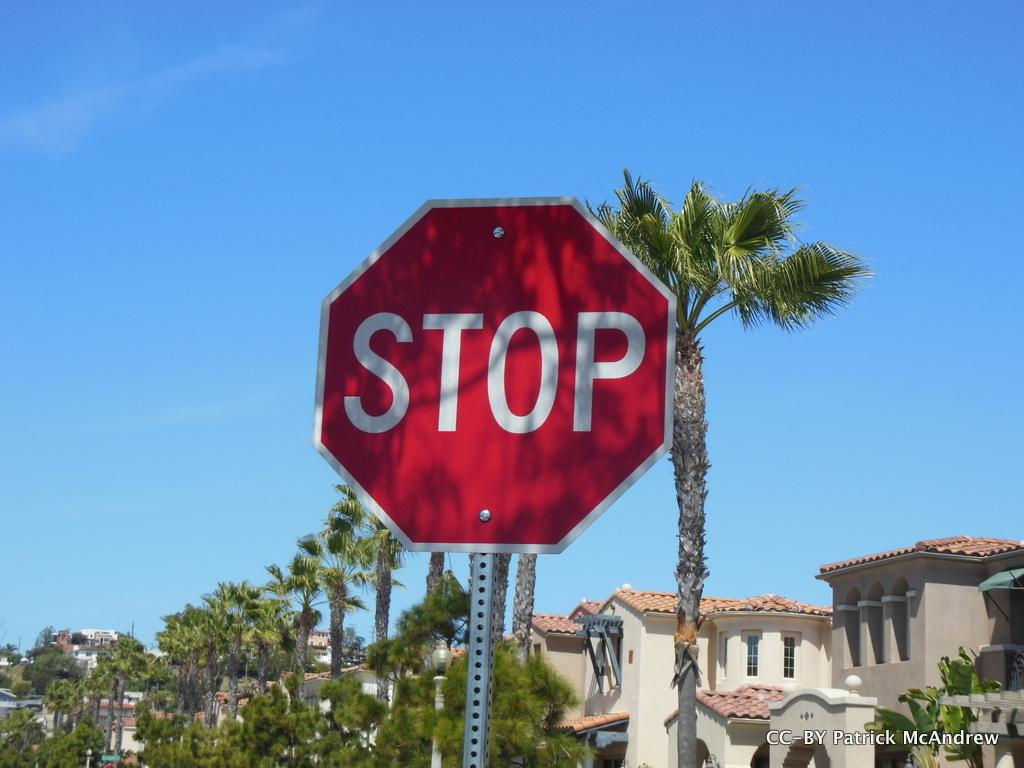<image>
Summarize the visual content of the image. A stop sign is located on a street that is lined with palm trees. 